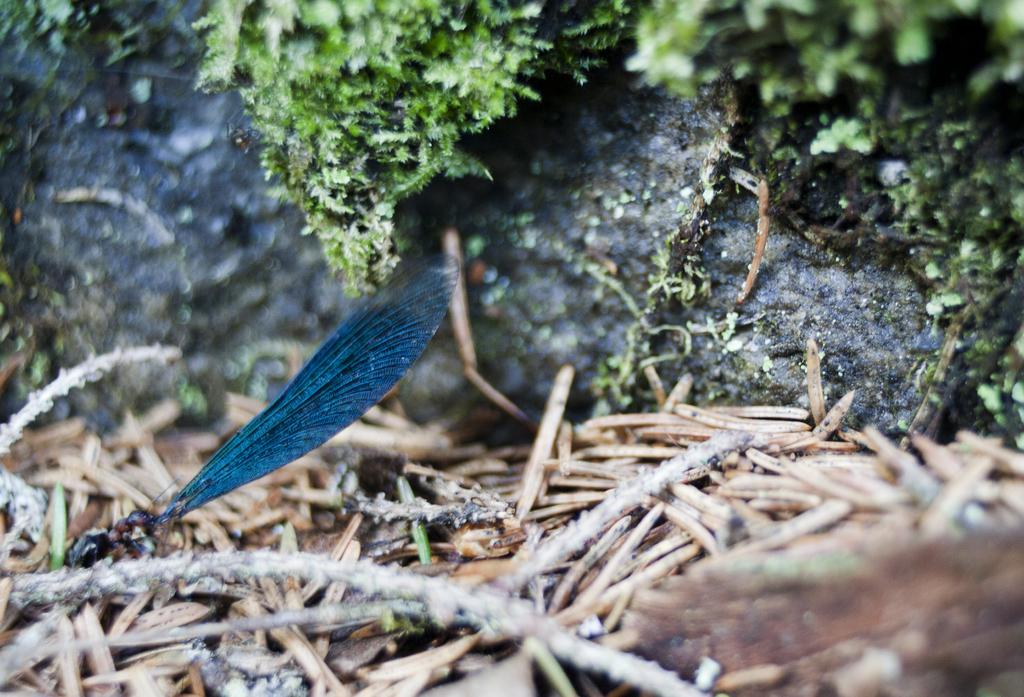What is the main subject of the image? There is an insect on a stem in the image. What can be seen in the background of the image? There is a rock with Moses in the background of the image. What else is visible on the ground in the image? There are other things visible on the ground in the image. How many children are playing with the skate in the image? There are no children or skates present in the image. What type of apparel is the insect wearing in the image? Insects do not wear apparel, and there is no indication of clothing in the image. 